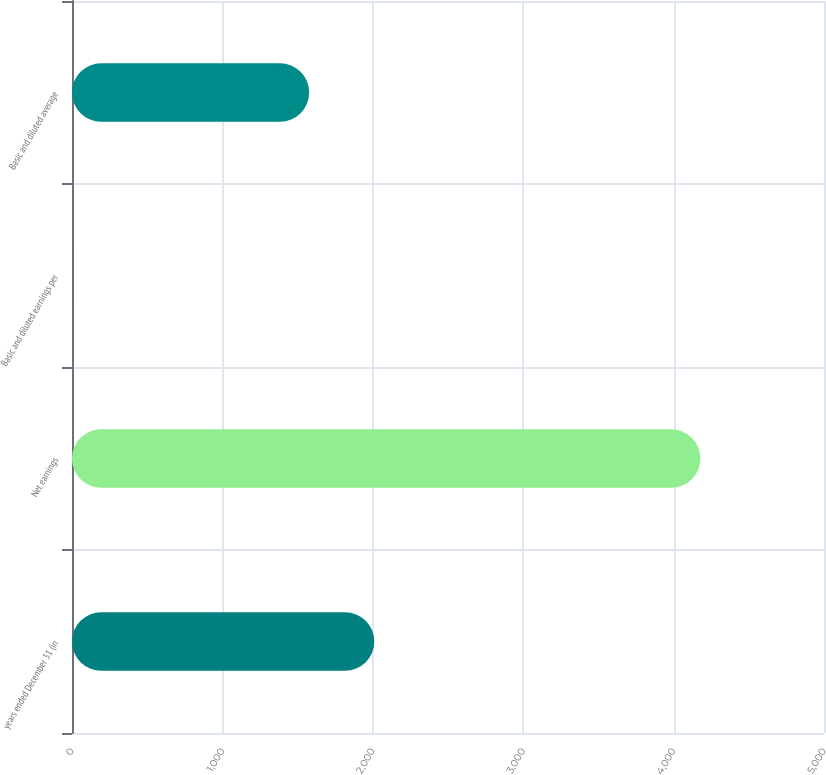Convert chart to OTSL. <chart><loc_0><loc_0><loc_500><loc_500><bar_chart><fcel>years ended December 31 (in<fcel>Net earnings<fcel>Basic and diluted earnings per<fcel>Basic and diluted average<nl><fcel>2010<fcel>4178<fcel>2.65<fcel>1577<nl></chart> 